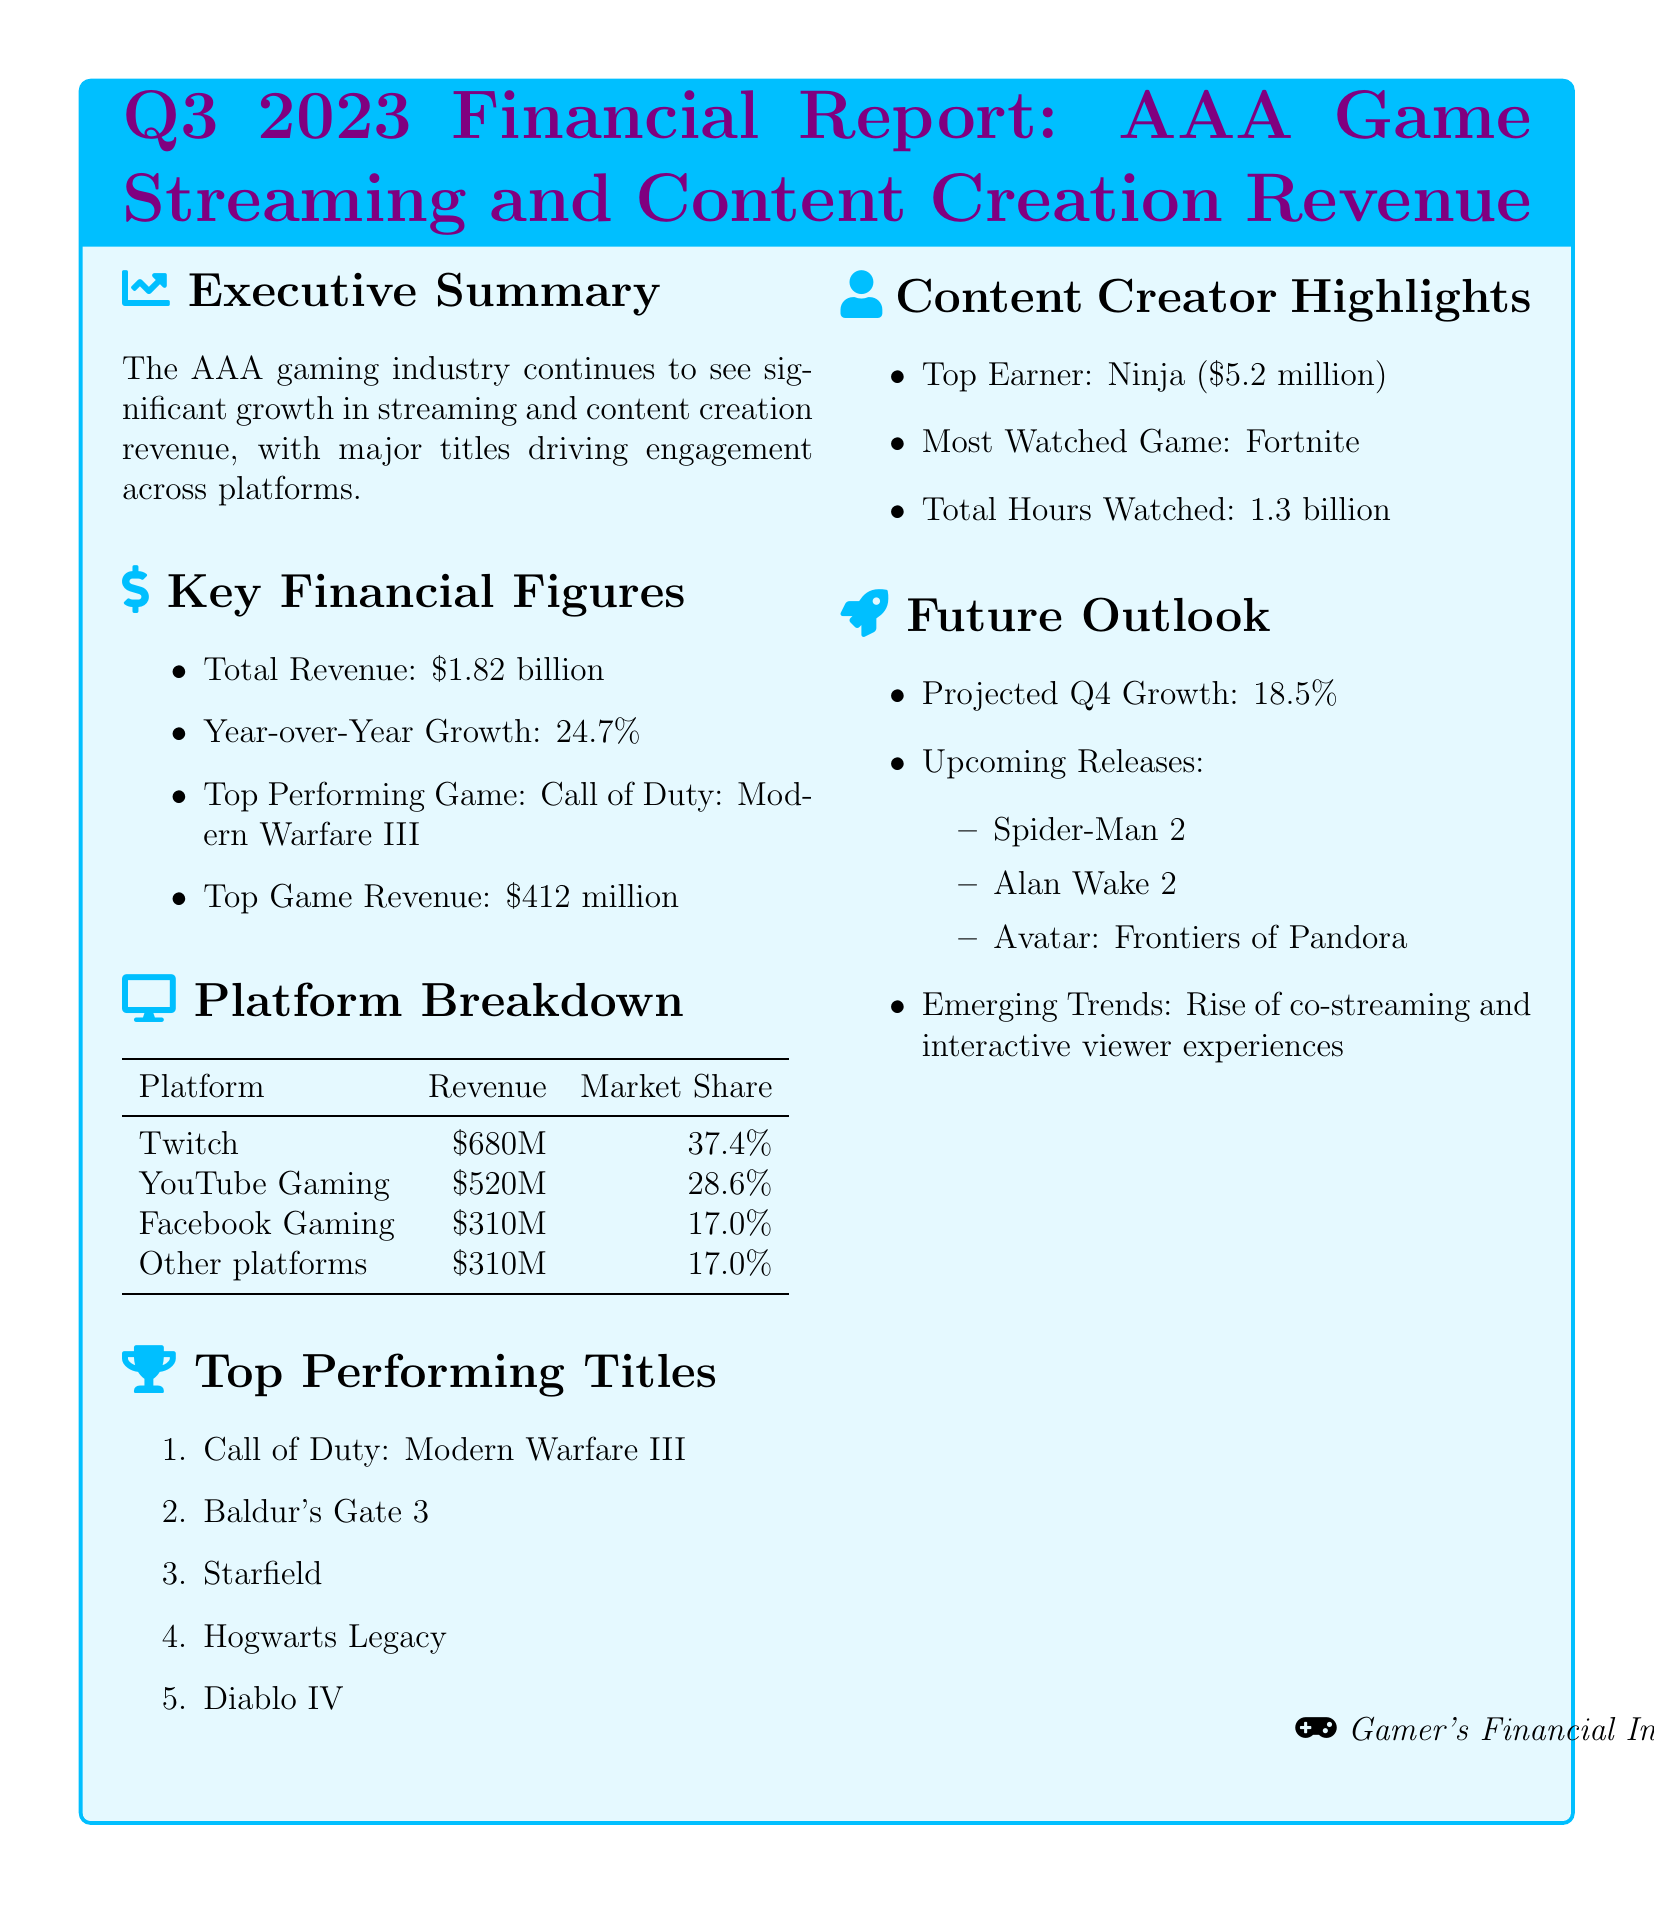What is the total revenue? The total revenue is stated in the key financial figures section of the document.
Answer: $1.82 billion What is the year-over-year growth percentage? This percentage indicates the increase in revenue compared to the previous year, as noted in the key financial figures.
Answer: 24.7% Which game generated the highest revenue? The document specifies the top-performing game and its corresponding revenue figure.
Answer: Call of Duty: Modern Warfare III How much revenue did Twitch generate? The revenue generated by Twitch is detailed in the platform breakdown section.
Answer: $680 million Who was the top earner among content creators? The document highlights the top earner in the content creation space.
Answer: Ninja What is the projected growth for Q4 2023? This figure is provided in the future outlook section, indicating anticipated growth.
Answer: 18.5% Which game is mentioned as the most-watched? The document notes the game that garnered the most viewer hours among streamers.
Answer: Fortnite What are the three upcoming AAA game releases? The future outlook lists forthcoming titles, which provide insight into upcoming content for the AAA game industry.
Answer: Spider-Man 2, Alan Wake 2, Avatar: Frontiers of Pandora What market share did YouTube Gaming hold? The platform breakdown section indicates the market share percentage for YouTube Gaming.
Answer: 28.6% 